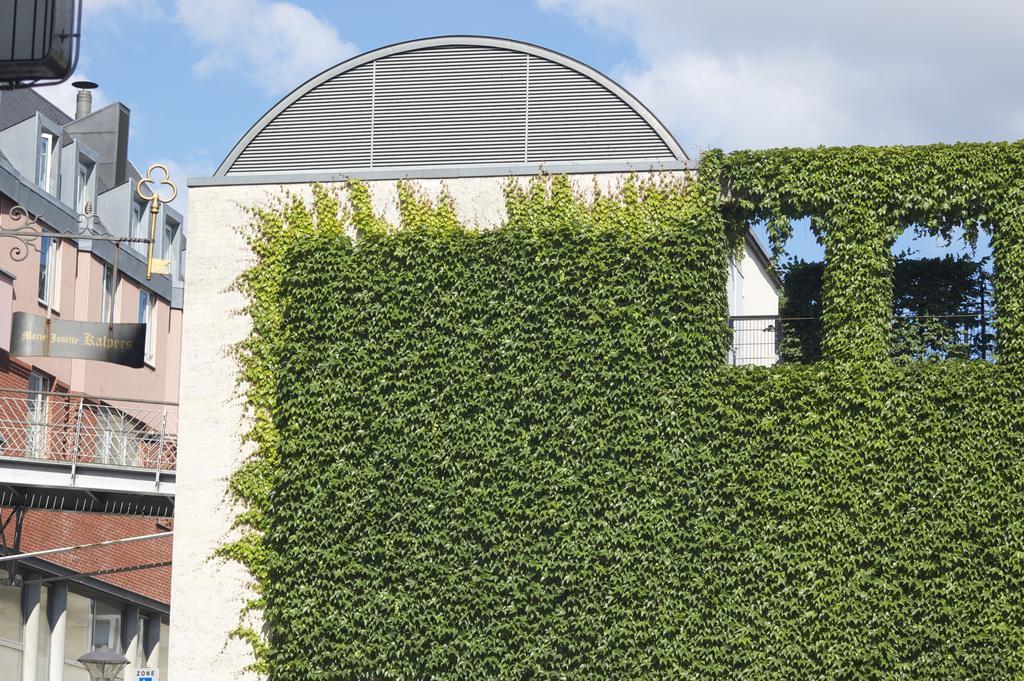Could you give a brief overview of what you see in this image? In this picture I can see buildings and plants and I can see a boat with some text and I can see a light at the bottom left corner and I can see blue cloudy sky. 